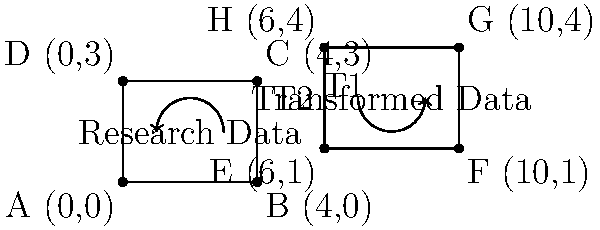In the context of international scientific collaboration, research data undergoes transformations as it moves across global networks. The original data set ABCD is transformed by T1 (translation of 6 units right and 1 unit up), followed by T2 (rotation of 90° clockwise around point E). What is the composite transformation T2 ∘ T1 that directly maps point A(0,0) to its final position? Let's approach this step-by-step:

1) First, we apply T1: Translation of 6 units right and 1 unit up
   This moves A(0,0) to E(6,1)

2) Then, we apply T2: Rotation of 90° clockwise around point E(6,1)
   To find the final position, we need to:
   a) Translate the center of rotation to the origin
   b) Apply the rotation
   c) Translate back

3) Let's call the final position of A as A'. We can represent this as:
   $$A' = R_{90°} \cdot (A + (6,1) - (6,1)) + (6,1)$$
   where $R_{90°}$ is the rotation matrix for 90° clockwise:
   $$R_{90°} = \begin{pmatrix} 0 & 1 \\ -1 & 0 \end{pmatrix}$$

4) Simplifying:
   $$A' = R_{90°} \cdot (0,0) + (6,1)$$
   $$A' = (0,0) + (6,1) = (6,1)$$

5) Therefore, the composite transformation T2 ∘ T1 maps A(0,0) to (6,1)

6) This composite transformation can be described as:
   "Translation of 6 units right and 1 unit up"

The rotation didn't affect the position of A because it was rotated around its new position after translation.
Answer: Translation of 6 units right and 1 unit up 